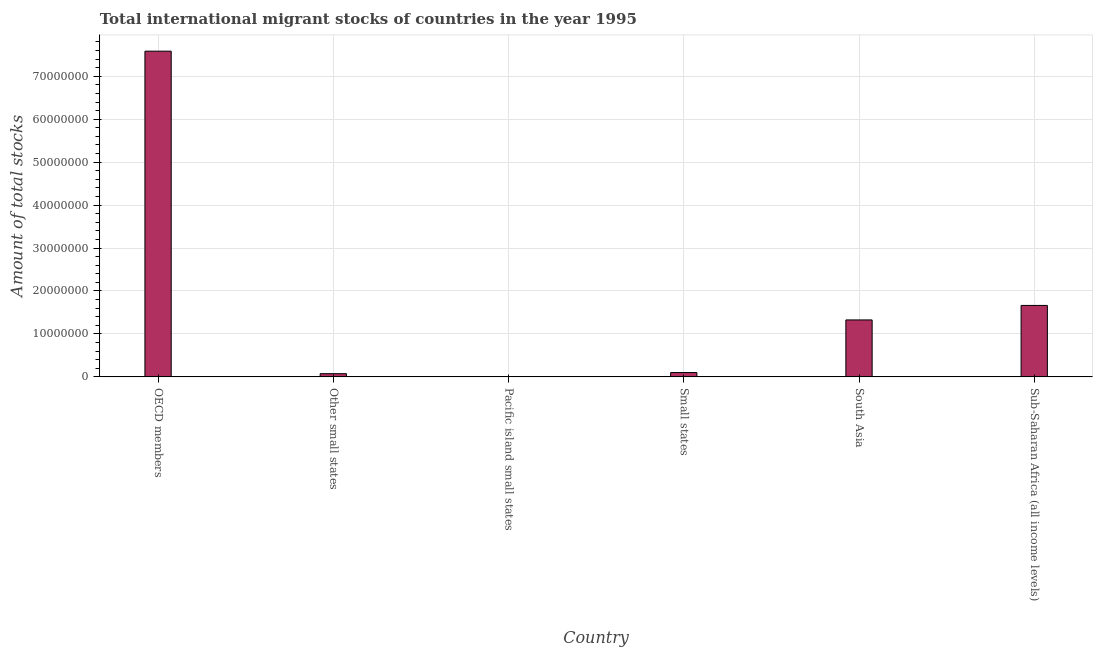Does the graph contain any zero values?
Give a very brief answer. No. What is the title of the graph?
Provide a succinct answer. Total international migrant stocks of countries in the year 1995. What is the label or title of the X-axis?
Your answer should be compact. Country. What is the label or title of the Y-axis?
Offer a very short reply. Amount of total stocks. What is the total number of international migrant stock in Other small states?
Offer a very short reply. 7.43e+05. Across all countries, what is the maximum total number of international migrant stock?
Keep it short and to the point. 7.58e+07. Across all countries, what is the minimum total number of international migrant stock?
Offer a terse response. 4.04e+04. In which country was the total number of international migrant stock maximum?
Make the answer very short. OECD members. In which country was the total number of international migrant stock minimum?
Ensure brevity in your answer.  Pacific island small states. What is the sum of the total number of international migrant stock?
Ensure brevity in your answer.  1.08e+08. What is the difference between the total number of international migrant stock in OECD members and Small states?
Your response must be concise. 7.48e+07. What is the average total number of international migrant stock per country?
Give a very brief answer. 1.79e+07. What is the median total number of international migrant stock?
Provide a succinct answer. 7.13e+06. What is the ratio of the total number of international migrant stock in Other small states to that in Small states?
Provide a short and direct response. 0.74. Is the total number of international migrant stock in Other small states less than that in Sub-Saharan Africa (all income levels)?
Keep it short and to the point. Yes. Is the difference between the total number of international migrant stock in Pacific island small states and Small states greater than the difference between any two countries?
Ensure brevity in your answer.  No. What is the difference between the highest and the second highest total number of international migrant stock?
Ensure brevity in your answer.  5.92e+07. What is the difference between the highest and the lowest total number of international migrant stock?
Ensure brevity in your answer.  7.58e+07. In how many countries, is the total number of international migrant stock greater than the average total number of international migrant stock taken over all countries?
Keep it short and to the point. 1. How many bars are there?
Offer a very short reply. 6. Are all the bars in the graph horizontal?
Offer a terse response. No. How many countries are there in the graph?
Your answer should be compact. 6. What is the Amount of total stocks of OECD members?
Ensure brevity in your answer.  7.58e+07. What is the Amount of total stocks in Other small states?
Ensure brevity in your answer.  7.43e+05. What is the Amount of total stocks in Pacific island small states?
Your response must be concise. 4.04e+04. What is the Amount of total stocks in Small states?
Your response must be concise. 1.01e+06. What is the Amount of total stocks in South Asia?
Make the answer very short. 1.33e+07. What is the Amount of total stocks in Sub-Saharan Africa (all income levels)?
Offer a very short reply. 1.66e+07. What is the difference between the Amount of total stocks in OECD members and Other small states?
Your answer should be very brief. 7.51e+07. What is the difference between the Amount of total stocks in OECD members and Pacific island small states?
Make the answer very short. 7.58e+07. What is the difference between the Amount of total stocks in OECD members and Small states?
Your answer should be very brief. 7.48e+07. What is the difference between the Amount of total stocks in OECD members and South Asia?
Make the answer very short. 6.26e+07. What is the difference between the Amount of total stocks in OECD members and Sub-Saharan Africa (all income levels)?
Offer a terse response. 5.92e+07. What is the difference between the Amount of total stocks in Other small states and Pacific island small states?
Offer a terse response. 7.03e+05. What is the difference between the Amount of total stocks in Other small states and Small states?
Offer a terse response. -2.64e+05. What is the difference between the Amount of total stocks in Other small states and South Asia?
Give a very brief answer. -1.25e+07. What is the difference between the Amount of total stocks in Other small states and Sub-Saharan Africa (all income levels)?
Your answer should be compact. -1.59e+07. What is the difference between the Amount of total stocks in Pacific island small states and Small states?
Ensure brevity in your answer.  -9.67e+05. What is the difference between the Amount of total stocks in Pacific island small states and South Asia?
Offer a terse response. -1.32e+07. What is the difference between the Amount of total stocks in Pacific island small states and Sub-Saharan Africa (all income levels)?
Keep it short and to the point. -1.66e+07. What is the difference between the Amount of total stocks in Small states and South Asia?
Offer a terse response. -1.22e+07. What is the difference between the Amount of total stocks in Small states and Sub-Saharan Africa (all income levels)?
Keep it short and to the point. -1.56e+07. What is the difference between the Amount of total stocks in South Asia and Sub-Saharan Africa (all income levels)?
Provide a short and direct response. -3.38e+06. What is the ratio of the Amount of total stocks in OECD members to that in Other small states?
Your answer should be compact. 102.08. What is the ratio of the Amount of total stocks in OECD members to that in Pacific island small states?
Offer a very short reply. 1878.72. What is the ratio of the Amount of total stocks in OECD members to that in Small states?
Ensure brevity in your answer.  75.31. What is the ratio of the Amount of total stocks in OECD members to that in South Asia?
Make the answer very short. 5.72. What is the ratio of the Amount of total stocks in OECD members to that in Sub-Saharan Africa (all income levels)?
Give a very brief answer. 4.56. What is the ratio of the Amount of total stocks in Other small states to that in Pacific island small states?
Offer a very short reply. 18.4. What is the ratio of the Amount of total stocks in Other small states to that in Small states?
Offer a terse response. 0.74. What is the ratio of the Amount of total stocks in Other small states to that in South Asia?
Your answer should be very brief. 0.06. What is the ratio of the Amount of total stocks in Other small states to that in Sub-Saharan Africa (all income levels)?
Provide a short and direct response. 0.04. What is the ratio of the Amount of total stocks in Pacific island small states to that in South Asia?
Ensure brevity in your answer.  0. What is the ratio of the Amount of total stocks in Pacific island small states to that in Sub-Saharan Africa (all income levels)?
Make the answer very short. 0. What is the ratio of the Amount of total stocks in Small states to that in South Asia?
Provide a short and direct response. 0.08. What is the ratio of the Amount of total stocks in Small states to that in Sub-Saharan Africa (all income levels)?
Keep it short and to the point. 0.06. What is the ratio of the Amount of total stocks in South Asia to that in Sub-Saharan Africa (all income levels)?
Your response must be concise. 0.8. 